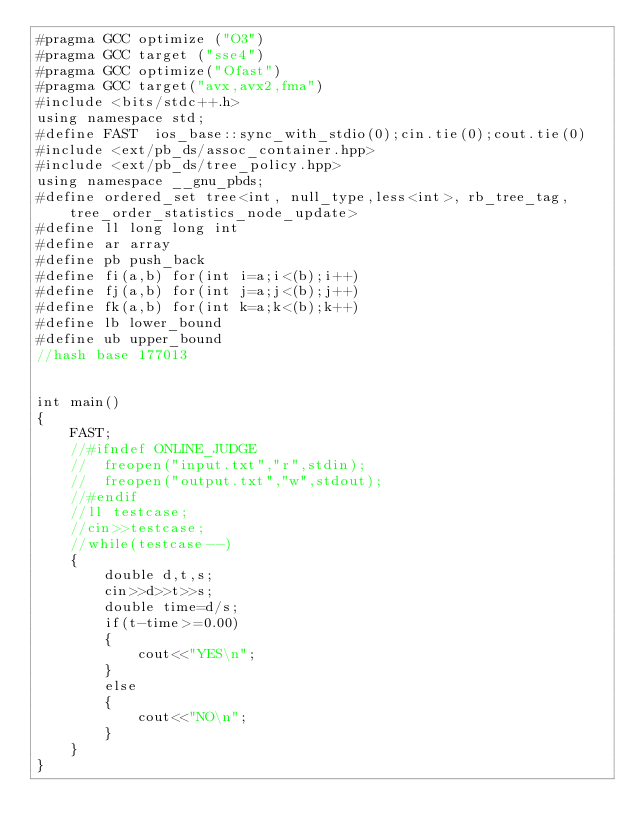<code> <loc_0><loc_0><loc_500><loc_500><_C++_>#pragma GCC optimize ("O3")
#pragma GCC target ("sse4")
#pragma GCC optimize("Ofast")
#pragma GCC target("avx,avx2,fma")
#include <bits/stdc++.h>
using namespace std;
#define FAST  ios_base::sync_with_stdio(0);cin.tie(0);cout.tie(0)
#include <ext/pb_ds/assoc_container.hpp> 
#include <ext/pb_ds/tree_policy.hpp> 
using namespace __gnu_pbds; 
#define ordered_set tree<int, null_type,less<int>, rb_tree_tag,tree_order_statistics_node_update> 
#define ll long long int 
#define ar array
#define pb push_back
#define fi(a,b) for(int i=a;i<(b);i++)
#define fj(a,b) for(int j=a;j<(b);j++)
#define fk(a,b) for(int k=a;k<(b);k++)
#define lb lower_bound
#define ub upper_bound
//hash base 177013


int main()
{
	FAST;
	//#ifndef ONLINE_JUDGE
	//	freopen("input.txt","r",stdin);
	//	freopen("output.txt","w",stdout);
	//#endif
	//ll testcase;
	//cin>>testcase;
	//while(testcase--)
	{
		double d,t,s;
		cin>>d>>t>>s;
		double time=d/s;
		if(t-time>=0.00)
		{
			cout<<"YES\n";
		}
		else
		{
			cout<<"NO\n";
		}
	}
}
























</code> 